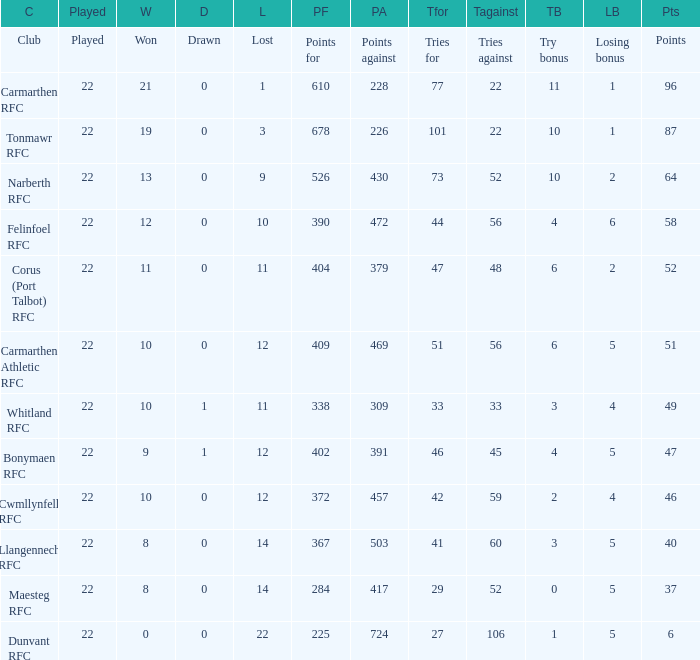Name the try bonus of points against at 430 10.0. 